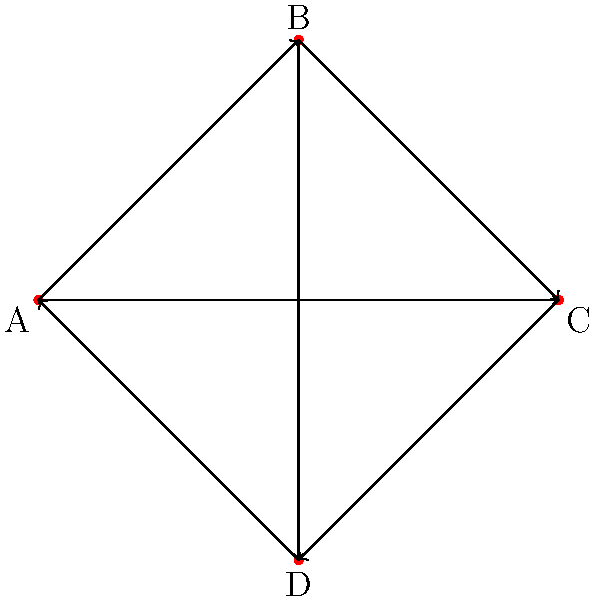In a play with four characters (A, B, C, and D), you've mapped their dialogue flow using a directed graph. Each character is represented by a vertex, and each directed edge indicates a line of dialogue from one character to another. Given the graph above, what is the minimum number of dialogue exchanges needed for the information to potentially reach all characters if it starts with character A? To solve this problem, we need to follow these steps:

1. Identify the starting point: Character A

2. Trace the possible paths from A to reach all other characters:
   - A can directly speak to B and C
   - A cannot directly speak to D

3. Find the shortest path to reach D:
   - A → B → D (2 exchanges)
   - A → C → D (2 exchanges)

4. Verify if all characters can be reached:
   - A is the starting point
   - B can be reached directly from A (1 exchange)
   - C can be reached directly from A (1 exchange)
   - D can be reached in 2 exchanges (either through B or C)

5. Determine the minimum number of exchanges:
   The minimum number of exchanges needed is the maximum of all these paths, which is 2.

This ensures that the information potentially reaches all characters, including the farthest one (D) from the starting point (A).
Answer: 2 